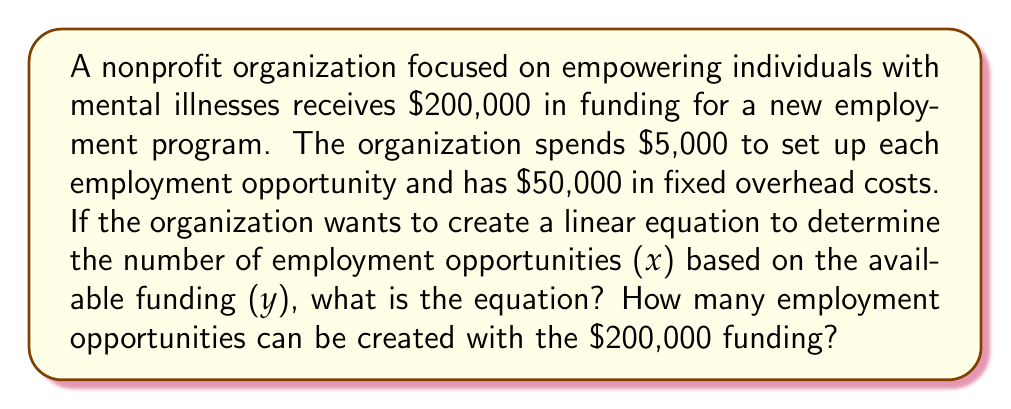Could you help me with this problem? Let's approach this step-by-step:

1) First, we need to identify the variables:
   x = number of employment opportunities
   y = available funding

2) We know that each employment opportunity costs $5,000 to set up. This is our variable cost.

3) There is a fixed overhead cost of $50,000.

4) We can now create a linear equation:
   $y = 5000x + 50000$

   Where:
   - 5000x represents the variable cost ($5,000 per opportunity)
   - 50000 represents the fixed overhead cost

5) To find how many opportunities can be created with $200,000:
   $200000 = 5000x + 50000$

6) Solve for x:
   $200000 - 50000 = 5000x$
   $150000 = 5000x$
   $x = 150000 / 5000 = 30$

Therefore, with $200,000 in funding, the organization can create 30 employment opportunities.
Answer: The linear equation is $y = 5000x + 50000$, where y is the available funding and x is the number of employment opportunities. With $200,000 in funding, 30 employment opportunities can be created. 